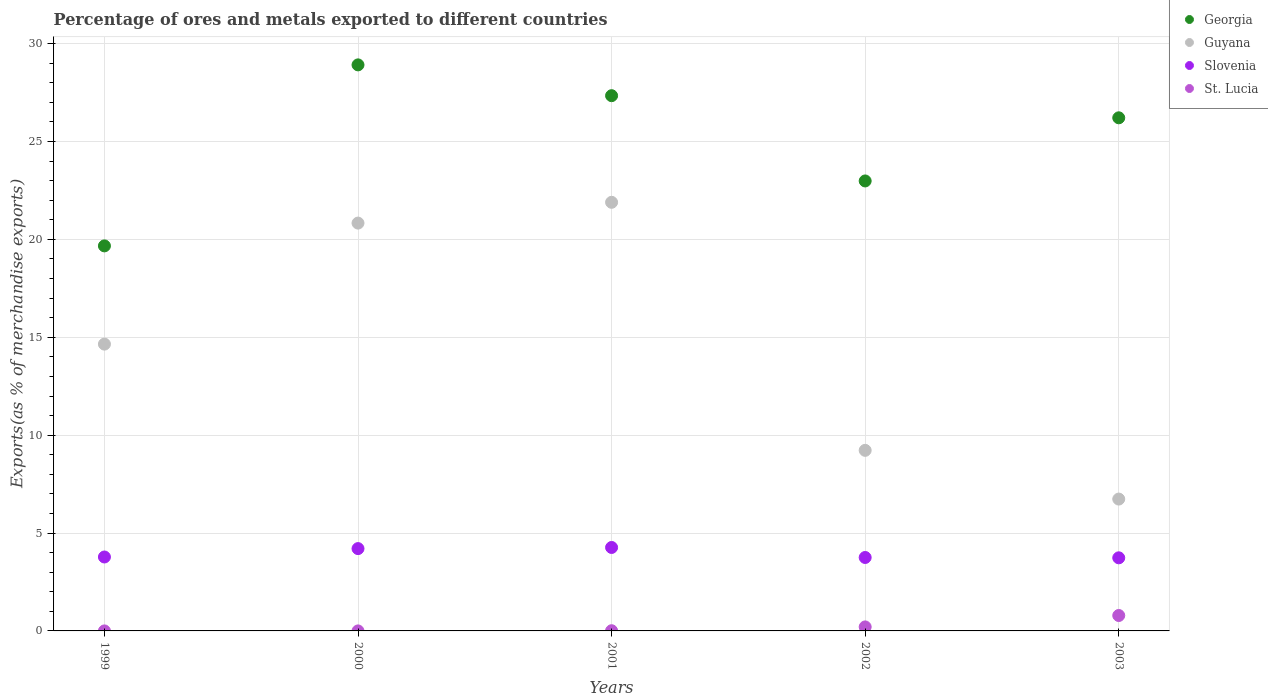How many different coloured dotlines are there?
Your answer should be compact. 4. What is the percentage of exports to different countries in Slovenia in 2000?
Your answer should be compact. 4.21. Across all years, what is the maximum percentage of exports to different countries in Guyana?
Offer a very short reply. 21.9. Across all years, what is the minimum percentage of exports to different countries in St. Lucia?
Give a very brief answer. 0. In which year was the percentage of exports to different countries in Georgia maximum?
Make the answer very short. 2000. In which year was the percentage of exports to different countries in St. Lucia minimum?
Your answer should be compact. 1999. What is the total percentage of exports to different countries in Guyana in the graph?
Your answer should be compact. 73.34. What is the difference between the percentage of exports to different countries in Slovenia in 2001 and that in 2003?
Offer a very short reply. 0.53. What is the difference between the percentage of exports to different countries in Guyana in 2003 and the percentage of exports to different countries in St. Lucia in 1999?
Your answer should be compact. 6.74. What is the average percentage of exports to different countries in Guyana per year?
Your answer should be very brief. 14.67. In the year 2002, what is the difference between the percentage of exports to different countries in Slovenia and percentage of exports to different countries in Georgia?
Provide a succinct answer. -19.24. In how many years, is the percentage of exports to different countries in Georgia greater than 20 %?
Keep it short and to the point. 4. What is the ratio of the percentage of exports to different countries in Slovenia in 2001 to that in 2003?
Your response must be concise. 1.14. Is the difference between the percentage of exports to different countries in Slovenia in 1999 and 2003 greater than the difference between the percentage of exports to different countries in Georgia in 1999 and 2003?
Offer a very short reply. Yes. What is the difference between the highest and the second highest percentage of exports to different countries in Slovenia?
Your answer should be very brief. 0.06. What is the difference between the highest and the lowest percentage of exports to different countries in Georgia?
Ensure brevity in your answer.  9.25. Is it the case that in every year, the sum of the percentage of exports to different countries in Georgia and percentage of exports to different countries in Guyana  is greater than the sum of percentage of exports to different countries in Slovenia and percentage of exports to different countries in St. Lucia?
Make the answer very short. No. Is it the case that in every year, the sum of the percentage of exports to different countries in Slovenia and percentage of exports to different countries in Georgia  is greater than the percentage of exports to different countries in St. Lucia?
Your answer should be compact. Yes. Does the percentage of exports to different countries in St. Lucia monotonically increase over the years?
Your answer should be very brief. Yes. Is the percentage of exports to different countries in Guyana strictly greater than the percentage of exports to different countries in Georgia over the years?
Ensure brevity in your answer.  No. How many years are there in the graph?
Provide a short and direct response. 5. What is the difference between two consecutive major ticks on the Y-axis?
Offer a very short reply. 5. Does the graph contain any zero values?
Provide a succinct answer. No. What is the title of the graph?
Make the answer very short. Percentage of ores and metals exported to different countries. What is the label or title of the Y-axis?
Your response must be concise. Exports(as % of merchandise exports). What is the Exports(as % of merchandise exports) of Georgia in 1999?
Offer a terse response. 19.67. What is the Exports(as % of merchandise exports) in Guyana in 1999?
Make the answer very short. 14.65. What is the Exports(as % of merchandise exports) of Slovenia in 1999?
Offer a very short reply. 3.78. What is the Exports(as % of merchandise exports) in St. Lucia in 1999?
Provide a short and direct response. 0. What is the Exports(as % of merchandise exports) in Georgia in 2000?
Your answer should be very brief. 28.92. What is the Exports(as % of merchandise exports) in Guyana in 2000?
Ensure brevity in your answer.  20.83. What is the Exports(as % of merchandise exports) of Slovenia in 2000?
Your answer should be compact. 4.21. What is the Exports(as % of merchandise exports) in St. Lucia in 2000?
Keep it short and to the point. 0. What is the Exports(as % of merchandise exports) in Georgia in 2001?
Give a very brief answer. 27.34. What is the Exports(as % of merchandise exports) of Guyana in 2001?
Offer a very short reply. 21.9. What is the Exports(as % of merchandise exports) in Slovenia in 2001?
Give a very brief answer. 4.26. What is the Exports(as % of merchandise exports) of St. Lucia in 2001?
Offer a terse response. 0.01. What is the Exports(as % of merchandise exports) in Georgia in 2002?
Provide a short and direct response. 22.99. What is the Exports(as % of merchandise exports) of Guyana in 2002?
Offer a terse response. 9.22. What is the Exports(as % of merchandise exports) of Slovenia in 2002?
Provide a short and direct response. 3.75. What is the Exports(as % of merchandise exports) of St. Lucia in 2002?
Give a very brief answer. 0.2. What is the Exports(as % of merchandise exports) of Georgia in 2003?
Your answer should be compact. 26.21. What is the Exports(as % of merchandise exports) of Guyana in 2003?
Give a very brief answer. 6.74. What is the Exports(as % of merchandise exports) of Slovenia in 2003?
Offer a terse response. 3.73. What is the Exports(as % of merchandise exports) of St. Lucia in 2003?
Your answer should be compact. 0.79. Across all years, what is the maximum Exports(as % of merchandise exports) in Georgia?
Give a very brief answer. 28.92. Across all years, what is the maximum Exports(as % of merchandise exports) of Guyana?
Offer a very short reply. 21.9. Across all years, what is the maximum Exports(as % of merchandise exports) of Slovenia?
Ensure brevity in your answer.  4.26. Across all years, what is the maximum Exports(as % of merchandise exports) of St. Lucia?
Your response must be concise. 0.79. Across all years, what is the minimum Exports(as % of merchandise exports) of Georgia?
Ensure brevity in your answer.  19.67. Across all years, what is the minimum Exports(as % of merchandise exports) in Guyana?
Your answer should be compact. 6.74. Across all years, what is the minimum Exports(as % of merchandise exports) in Slovenia?
Give a very brief answer. 3.73. Across all years, what is the minimum Exports(as % of merchandise exports) of St. Lucia?
Provide a short and direct response. 0. What is the total Exports(as % of merchandise exports) of Georgia in the graph?
Give a very brief answer. 125.13. What is the total Exports(as % of merchandise exports) in Guyana in the graph?
Your answer should be very brief. 73.34. What is the total Exports(as % of merchandise exports) of Slovenia in the graph?
Your response must be concise. 19.73. What is the difference between the Exports(as % of merchandise exports) in Georgia in 1999 and that in 2000?
Provide a short and direct response. -9.25. What is the difference between the Exports(as % of merchandise exports) of Guyana in 1999 and that in 2000?
Keep it short and to the point. -6.18. What is the difference between the Exports(as % of merchandise exports) in Slovenia in 1999 and that in 2000?
Offer a terse response. -0.43. What is the difference between the Exports(as % of merchandise exports) in St. Lucia in 1999 and that in 2000?
Keep it short and to the point. -0. What is the difference between the Exports(as % of merchandise exports) in Georgia in 1999 and that in 2001?
Your answer should be compact. -7.67. What is the difference between the Exports(as % of merchandise exports) in Guyana in 1999 and that in 2001?
Give a very brief answer. -7.25. What is the difference between the Exports(as % of merchandise exports) of Slovenia in 1999 and that in 2001?
Give a very brief answer. -0.49. What is the difference between the Exports(as % of merchandise exports) of St. Lucia in 1999 and that in 2001?
Keep it short and to the point. -0.01. What is the difference between the Exports(as % of merchandise exports) in Georgia in 1999 and that in 2002?
Your answer should be compact. -3.32. What is the difference between the Exports(as % of merchandise exports) of Guyana in 1999 and that in 2002?
Your answer should be compact. 5.43. What is the difference between the Exports(as % of merchandise exports) in Slovenia in 1999 and that in 2002?
Give a very brief answer. 0.03. What is the difference between the Exports(as % of merchandise exports) of St. Lucia in 1999 and that in 2002?
Offer a very short reply. -0.2. What is the difference between the Exports(as % of merchandise exports) of Georgia in 1999 and that in 2003?
Your answer should be very brief. -6.54. What is the difference between the Exports(as % of merchandise exports) of Guyana in 1999 and that in 2003?
Offer a very short reply. 7.92. What is the difference between the Exports(as % of merchandise exports) of Slovenia in 1999 and that in 2003?
Your answer should be very brief. 0.04. What is the difference between the Exports(as % of merchandise exports) of St. Lucia in 1999 and that in 2003?
Offer a terse response. -0.79. What is the difference between the Exports(as % of merchandise exports) in Georgia in 2000 and that in 2001?
Your answer should be compact. 1.57. What is the difference between the Exports(as % of merchandise exports) of Guyana in 2000 and that in 2001?
Provide a short and direct response. -1.06. What is the difference between the Exports(as % of merchandise exports) of Slovenia in 2000 and that in 2001?
Provide a short and direct response. -0.06. What is the difference between the Exports(as % of merchandise exports) of St. Lucia in 2000 and that in 2001?
Provide a succinct answer. -0.01. What is the difference between the Exports(as % of merchandise exports) in Georgia in 2000 and that in 2002?
Provide a short and direct response. 5.93. What is the difference between the Exports(as % of merchandise exports) in Guyana in 2000 and that in 2002?
Provide a short and direct response. 11.61. What is the difference between the Exports(as % of merchandise exports) of Slovenia in 2000 and that in 2002?
Offer a terse response. 0.45. What is the difference between the Exports(as % of merchandise exports) of St. Lucia in 2000 and that in 2002?
Offer a very short reply. -0.2. What is the difference between the Exports(as % of merchandise exports) of Georgia in 2000 and that in 2003?
Provide a short and direct response. 2.7. What is the difference between the Exports(as % of merchandise exports) in Guyana in 2000 and that in 2003?
Your answer should be compact. 14.1. What is the difference between the Exports(as % of merchandise exports) in Slovenia in 2000 and that in 2003?
Offer a terse response. 0.47. What is the difference between the Exports(as % of merchandise exports) in St. Lucia in 2000 and that in 2003?
Make the answer very short. -0.79. What is the difference between the Exports(as % of merchandise exports) of Georgia in 2001 and that in 2002?
Your answer should be compact. 4.36. What is the difference between the Exports(as % of merchandise exports) in Guyana in 2001 and that in 2002?
Provide a short and direct response. 12.67. What is the difference between the Exports(as % of merchandise exports) of Slovenia in 2001 and that in 2002?
Provide a succinct answer. 0.51. What is the difference between the Exports(as % of merchandise exports) of St. Lucia in 2001 and that in 2002?
Your answer should be compact. -0.19. What is the difference between the Exports(as % of merchandise exports) of Georgia in 2001 and that in 2003?
Offer a terse response. 1.13. What is the difference between the Exports(as % of merchandise exports) of Guyana in 2001 and that in 2003?
Ensure brevity in your answer.  15.16. What is the difference between the Exports(as % of merchandise exports) of Slovenia in 2001 and that in 2003?
Offer a terse response. 0.53. What is the difference between the Exports(as % of merchandise exports) in St. Lucia in 2001 and that in 2003?
Your response must be concise. -0.78. What is the difference between the Exports(as % of merchandise exports) of Georgia in 2002 and that in 2003?
Your response must be concise. -3.23. What is the difference between the Exports(as % of merchandise exports) in Guyana in 2002 and that in 2003?
Your response must be concise. 2.49. What is the difference between the Exports(as % of merchandise exports) in Slovenia in 2002 and that in 2003?
Offer a very short reply. 0.02. What is the difference between the Exports(as % of merchandise exports) in St. Lucia in 2002 and that in 2003?
Your response must be concise. -0.58. What is the difference between the Exports(as % of merchandise exports) of Georgia in 1999 and the Exports(as % of merchandise exports) of Guyana in 2000?
Give a very brief answer. -1.16. What is the difference between the Exports(as % of merchandise exports) of Georgia in 1999 and the Exports(as % of merchandise exports) of Slovenia in 2000?
Make the answer very short. 15.46. What is the difference between the Exports(as % of merchandise exports) of Georgia in 1999 and the Exports(as % of merchandise exports) of St. Lucia in 2000?
Your answer should be very brief. 19.67. What is the difference between the Exports(as % of merchandise exports) in Guyana in 1999 and the Exports(as % of merchandise exports) in Slovenia in 2000?
Offer a very short reply. 10.45. What is the difference between the Exports(as % of merchandise exports) of Guyana in 1999 and the Exports(as % of merchandise exports) of St. Lucia in 2000?
Give a very brief answer. 14.65. What is the difference between the Exports(as % of merchandise exports) of Slovenia in 1999 and the Exports(as % of merchandise exports) of St. Lucia in 2000?
Your response must be concise. 3.78. What is the difference between the Exports(as % of merchandise exports) in Georgia in 1999 and the Exports(as % of merchandise exports) in Guyana in 2001?
Ensure brevity in your answer.  -2.23. What is the difference between the Exports(as % of merchandise exports) in Georgia in 1999 and the Exports(as % of merchandise exports) in Slovenia in 2001?
Your answer should be compact. 15.41. What is the difference between the Exports(as % of merchandise exports) of Georgia in 1999 and the Exports(as % of merchandise exports) of St. Lucia in 2001?
Make the answer very short. 19.66. What is the difference between the Exports(as % of merchandise exports) of Guyana in 1999 and the Exports(as % of merchandise exports) of Slovenia in 2001?
Provide a short and direct response. 10.39. What is the difference between the Exports(as % of merchandise exports) in Guyana in 1999 and the Exports(as % of merchandise exports) in St. Lucia in 2001?
Make the answer very short. 14.64. What is the difference between the Exports(as % of merchandise exports) of Slovenia in 1999 and the Exports(as % of merchandise exports) of St. Lucia in 2001?
Keep it short and to the point. 3.77. What is the difference between the Exports(as % of merchandise exports) of Georgia in 1999 and the Exports(as % of merchandise exports) of Guyana in 2002?
Provide a succinct answer. 10.45. What is the difference between the Exports(as % of merchandise exports) in Georgia in 1999 and the Exports(as % of merchandise exports) in Slovenia in 2002?
Ensure brevity in your answer.  15.92. What is the difference between the Exports(as % of merchandise exports) of Georgia in 1999 and the Exports(as % of merchandise exports) of St. Lucia in 2002?
Provide a short and direct response. 19.47. What is the difference between the Exports(as % of merchandise exports) of Guyana in 1999 and the Exports(as % of merchandise exports) of Slovenia in 2002?
Provide a succinct answer. 10.9. What is the difference between the Exports(as % of merchandise exports) in Guyana in 1999 and the Exports(as % of merchandise exports) in St. Lucia in 2002?
Your answer should be compact. 14.45. What is the difference between the Exports(as % of merchandise exports) of Slovenia in 1999 and the Exports(as % of merchandise exports) of St. Lucia in 2002?
Offer a terse response. 3.57. What is the difference between the Exports(as % of merchandise exports) of Georgia in 1999 and the Exports(as % of merchandise exports) of Guyana in 2003?
Keep it short and to the point. 12.93. What is the difference between the Exports(as % of merchandise exports) of Georgia in 1999 and the Exports(as % of merchandise exports) of Slovenia in 2003?
Make the answer very short. 15.94. What is the difference between the Exports(as % of merchandise exports) of Georgia in 1999 and the Exports(as % of merchandise exports) of St. Lucia in 2003?
Provide a succinct answer. 18.88. What is the difference between the Exports(as % of merchandise exports) of Guyana in 1999 and the Exports(as % of merchandise exports) of Slovenia in 2003?
Give a very brief answer. 10.92. What is the difference between the Exports(as % of merchandise exports) of Guyana in 1999 and the Exports(as % of merchandise exports) of St. Lucia in 2003?
Offer a very short reply. 13.86. What is the difference between the Exports(as % of merchandise exports) of Slovenia in 1999 and the Exports(as % of merchandise exports) of St. Lucia in 2003?
Give a very brief answer. 2.99. What is the difference between the Exports(as % of merchandise exports) in Georgia in 2000 and the Exports(as % of merchandise exports) in Guyana in 2001?
Provide a short and direct response. 7.02. What is the difference between the Exports(as % of merchandise exports) of Georgia in 2000 and the Exports(as % of merchandise exports) of Slovenia in 2001?
Your answer should be compact. 24.65. What is the difference between the Exports(as % of merchandise exports) in Georgia in 2000 and the Exports(as % of merchandise exports) in St. Lucia in 2001?
Ensure brevity in your answer.  28.91. What is the difference between the Exports(as % of merchandise exports) of Guyana in 2000 and the Exports(as % of merchandise exports) of Slovenia in 2001?
Your answer should be compact. 16.57. What is the difference between the Exports(as % of merchandise exports) in Guyana in 2000 and the Exports(as % of merchandise exports) in St. Lucia in 2001?
Your answer should be very brief. 20.82. What is the difference between the Exports(as % of merchandise exports) in Slovenia in 2000 and the Exports(as % of merchandise exports) in St. Lucia in 2001?
Your answer should be compact. 4.2. What is the difference between the Exports(as % of merchandise exports) of Georgia in 2000 and the Exports(as % of merchandise exports) of Guyana in 2002?
Your answer should be compact. 19.69. What is the difference between the Exports(as % of merchandise exports) in Georgia in 2000 and the Exports(as % of merchandise exports) in Slovenia in 2002?
Provide a succinct answer. 25.17. What is the difference between the Exports(as % of merchandise exports) in Georgia in 2000 and the Exports(as % of merchandise exports) in St. Lucia in 2002?
Your answer should be very brief. 28.71. What is the difference between the Exports(as % of merchandise exports) of Guyana in 2000 and the Exports(as % of merchandise exports) of Slovenia in 2002?
Provide a succinct answer. 17.08. What is the difference between the Exports(as % of merchandise exports) of Guyana in 2000 and the Exports(as % of merchandise exports) of St. Lucia in 2002?
Your response must be concise. 20.63. What is the difference between the Exports(as % of merchandise exports) in Slovenia in 2000 and the Exports(as % of merchandise exports) in St. Lucia in 2002?
Keep it short and to the point. 4. What is the difference between the Exports(as % of merchandise exports) in Georgia in 2000 and the Exports(as % of merchandise exports) in Guyana in 2003?
Give a very brief answer. 22.18. What is the difference between the Exports(as % of merchandise exports) of Georgia in 2000 and the Exports(as % of merchandise exports) of Slovenia in 2003?
Provide a succinct answer. 25.18. What is the difference between the Exports(as % of merchandise exports) in Georgia in 2000 and the Exports(as % of merchandise exports) in St. Lucia in 2003?
Keep it short and to the point. 28.13. What is the difference between the Exports(as % of merchandise exports) of Guyana in 2000 and the Exports(as % of merchandise exports) of Slovenia in 2003?
Provide a short and direct response. 17.1. What is the difference between the Exports(as % of merchandise exports) of Guyana in 2000 and the Exports(as % of merchandise exports) of St. Lucia in 2003?
Provide a short and direct response. 20.05. What is the difference between the Exports(as % of merchandise exports) in Slovenia in 2000 and the Exports(as % of merchandise exports) in St. Lucia in 2003?
Keep it short and to the point. 3.42. What is the difference between the Exports(as % of merchandise exports) of Georgia in 2001 and the Exports(as % of merchandise exports) of Guyana in 2002?
Give a very brief answer. 18.12. What is the difference between the Exports(as % of merchandise exports) in Georgia in 2001 and the Exports(as % of merchandise exports) in Slovenia in 2002?
Give a very brief answer. 23.59. What is the difference between the Exports(as % of merchandise exports) of Georgia in 2001 and the Exports(as % of merchandise exports) of St. Lucia in 2002?
Keep it short and to the point. 27.14. What is the difference between the Exports(as % of merchandise exports) of Guyana in 2001 and the Exports(as % of merchandise exports) of Slovenia in 2002?
Make the answer very short. 18.14. What is the difference between the Exports(as % of merchandise exports) in Guyana in 2001 and the Exports(as % of merchandise exports) in St. Lucia in 2002?
Give a very brief answer. 21.69. What is the difference between the Exports(as % of merchandise exports) of Slovenia in 2001 and the Exports(as % of merchandise exports) of St. Lucia in 2002?
Give a very brief answer. 4.06. What is the difference between the Exports(as % of merchandise exports) of Georgia in 2001 and the Exports(as % of merchandise exports) of Guyana in 2003?
Ensure brevity in your answer.  20.61. What is the difference between the Exports(as % of merchandise exports) of Georgia in 2001 and the Exports(as % of merchandise exports) of Slovenia in 2003?
Your answer should be very brief. 23.61. What is the difference between the Exports(as % of merchandise exports) in Georgia in 2001 and the Exports(as % of merchandise exports) in St. Lucia in 2003?
Provide a succinct answer. 26.56. What is the difference between the Exports(as % of merchandise exports) in Guyana in 2001 and the Exports(as % of merchandise exports) in Slovenia in 2003?
Offer a terse response. 18.16. What is the difference between the Exports(as % of merchandise exports) of Guyana in 2001 and the Exports(as % of merchandise exports) of St. Lucia in 2003?
Give a very brief answer. 21.11. What is the difference between the Exports(as % of merchandise exports) in Slovenia in 2001 and the Exports(as % of merchandise exports) in St. Lucia in 2003?
Ensure brevity in your answer.  3.48. What is the difference between the Exports(as % of merchandise exports) of Georgia in 2002 and the Exports(as % of merchandise exports) of Guyana in 2003?
Provide a short and direct response. 16.25. What is the difference between the Exports(as % of merchandise exports) of Georgia in 2002 and the Exports(as % of merchandise exports) of Slovenia in 2003?
Keep it short and to the point. 19.25. What is the difference between the Exports(as % of merchandise exports) in Georgia in 2002 and the Exports(as % of merchandise exports) in St. Lucia in 2003?
Your answer should be compact. 22.2. What is the difference between the Exports(as % of merchandise exports) in Guyana in 2002 and the Exports(as % of merchandise exports) in Slovenia in 2003?
Provide a succinct answer. 5.49. What is the difference between the Exports(as % of merchandise exports) in Guyana in 2002 and the Exports(as % of merchandise exports) in St. Lucia in 2003?
Make the answer very short. 8.44. What is the difference between the Exports(as % of merchandise exports) in Slovenia in 2002 and the Exports(as % of merchandise exports) in St. Lucia in 2003?
Give a very brief answer. 2.96. What is the average Exports(as % of merchandise exports) of Georgia per year?
Provide a short and direct response. 25.03. What is the average Exports(as % of merchandise exports) in Guyana per year?
Your answer should be compact. 14.67. What is the average Exports(as % of merchandise exports) of Slovenia per year?
Provide a short and direct response. 3.95. What is the average Exports(as % of merchandise exports) in St. Lucia per year?
Offer a very short reply. 0.2. In the year 1999, what is the difference between the Exports(as % of merchandise exports) in Georgia and Exports(as % of merchandise exports) in Guyana?
Provide a short and direct response. 5.02. In the year 1999, what is the difference between the Exports(as % of merchandise exports) of Georgia and Exports(as % of merchandise exports) of Slovenia?
Offer a very short reply. 15.89. In the year 1999, what is the difference between the Exports(as % of merchandise exports) in Georgia and Exports(as % of merchandise exports) in St. Lucia?
Offer a terse response. 19.67. In the year 1999, what is the difference between the Exports(as % of merchandise exports) of Guyana and Exports(as % of merchandise exports) of Slovenia?
Offer a terse response. 10.87. In the year 1999, what is the difference between the Exports(as % of merchandise exports) in Guyana and Exports(as % of merchandise exports) in St. Lucia?
Keep it short and to the point. 14.65. In the year 1999, what is the difference between the Exports(as % of merchandise exports) in Slovenia and Exports(as % of merchandise exports) in St. Lucia?
Ensure brevity in your answer.  3.78. In the year 2000, what is the difference between the Exports(as % of merchandise exports) in Georgia and Exports(as % of merchandise exports) in Guyana?
Keep it short and to the point. 8.08. In the year 2000, what is the difference between the Exports(as % of merchandise exports) in Georgia and Exports(as % of merchandise exports) in Slovenia?
Make the answer very short. 24.71. In the year 2000, what is the difference between the Exports(as % of merchandise exports) in Georgia and Exports(as % of merchandise exports) in St. Lucia?
Ensure brevity in your answer.  28.92. In the year 2000, what is the difference between the Exports(as % of merchandise exports) in Guyana and Exports(as % of merchandise exports) in Slovenia?
Offer a terse response. 16.63. In the year 2000, what is the difference between the Exports(as % of merchandise exports) in Guyana and Exports(as % of merchandise exports) in St. Lucia?
Your response must be concise. 20.83. In the year 2000, what is the difference between the Exports(as % of merchandise exports) in Slovenia and Exports(as % of merchandise exports) in St. Lucia?
Make the answer very short. 4.21. In the year 2001, what is the difference between the Exports(as % of merchandise exports) in Georgia and Exports(as % of merchandise exports) in Guyana?
Provide a succinct answer. 5.45. In the year 2001, what is the difference between the Exports(as % of merchandise exports) of Georgia and Exports(as % of merchandise exports) of Slovenia?
Offer a very short reply. 23.08. In the year 2001, what is the difference between the Exports(as % of merchandise exports) in Georgia and Exports(as % of merchandise exports) in St. Lucia?
Your answer should be compact. 27.33. In the year 2001, what is the difference between the Exports(as % of merchandise exports) of Guyana and Exports(as % of merchandise exports) of Slovenia?
Give a very brief answer. 17.63. In the year 2001, what is the difference between the Exports(as % of merchandise exports) of Guyana and Exports(as % of merchandise exports) of St. Lucia?
Offer a terse response. 21.89. In the year 2001, what is the difference between the Exports(as % of merchandise exports) of Slovenia and Exports(as % of merchandise exports) of St. Lucia?
Offer a very short reply. 4.25. In the year 2002, what is the difference between the Exports(as % of merchandise exports) of Georgia and Exports(as % of merchandise exports) of Guyana?
Your answer should be very brief. 13.76. In the year 2002, what is the difference between the Exports(as % of merchandise exports) in Georgia and Exports(as % of merchandise exports) in Slovenia?
Your answer should be very brief. 19.24. In the year 2002, what is the difference between the Exports(as % of merchandise exports) of Georgia and Exports(as % of merchandise exports) of St. Lucia?
Provide a short and direct response. 22.78. In the year 2002, what is the difference between the Exports(as % of merchandise exports) of Guyana and Exports(as % of merchandise exports) of Slovenia?
Provide a succinct answer. 5.47. In the year 2002, what is the difference between the Exports(as % of merchandise exports) in Guyana and Exports(as % of merchandise exports) in St. Lucia?
Offer a terse response. 9.02. In the year 2002, what is the difference between the Exports(as % of merchandise exports) in Slovenia and Exports(as % of merchandise exports) in St. Lucia?
Offer a terse response. 3.55. In the year 2003, what is the difference between the Exports(as % of merchandise exports) of Georgia and Exports(as % of merchandise exports) of Guyana?
Ensure brevity in your answer.  19.48. In the year 2003, what is the difference between the Exports(as % of merchandise exports) of Georgia and Exports(as % of merchandise exports) of Slovenia?
Ensure brevity in your answer.  22.48. In the year 2003, what is the difference between the Exports(as % of merchandise exports) in Georgia and Exports(as % of merchandise exports) in St. Lucia?
Provide a short and direct response. 25.43. In the year 2003, what is the difference between the Exports(as % of merchandise exports) in Guyana and Exports(as % of merchandise exports) in Slovenia?
Your answer should be very brief. 3. In the year 2003, what is the difference between the Exports(as % of merchandise exports) in Guyana and Exports(as % of merchandise exports) in St. Lucia?
Ensure brevity in your answer.  5.95. In the year 2003, what is the difference between the Exports(as % of merchandise exports) in Slovenia and Exports(as % of merchandise exports) in St. Lucia?
Make the answer very short. 2.95. What is the ratio of the Exports(as % of merchandise exports) in Georgia in 1999 to that in 2000?
Give a very brief answer. 0.68. What is the ratio of the Exports(as % of merchandise exports) of Guyana in 1999 to that in 2000?
Provide a short and direct response. 0.7. What is the ratio of the Exports(as % of merchandise exports) in Slovenia in 1999 to that in 2000?
Offer a terse response. 0.9. What is the ratio of the Exports(as % of merchandise exports) of St. Lucia in 1999 to that in 2000?
Provide a succinct answer. 0.72. What is the ratio of the Exports(as % of merchandise exports) in Georgia in 1999 to that in 2001?
Give a very brief answer. 0.72. What is the ratio of the Exports(as % of merchandise exports) in Guyana in 1999 to that in 2001?
Provide a short and direct response. 0.67. What is the ratio of the Exports(as % of merchandise exports) of Slovenia in 1999 to that in 2001?
Your response must be concise. 0.89. What is the ratio of the Exports(as % of merchandise exports) of St. Lucia in 1999 to that in 2001?
Give a very brief answer. 0.01. What is the ratio of the Exports(as % of merchandise exports) of Georgia in 1999 to that in 2002?
Provide a short and direct response. 0.86. What is the ratio of the Exports(as % of merchandise exports) of Guyana in 1999 to that in 2002?
Keep it short and to the point. 1.59. What is the ratio of the Exports(as % of merchandise exports) of Georgia in 1999 to that in 2003?
Offer a terse response. 0.75. What is the ratio of the Exports(as % of merchandise exports) in Guyana in 1999 to that in 2003?
Offer a very short reply. 2.18. What is the ratio of the Exports(as % of merchandise exports) of Slovenia in 1999 to that in 2003?
Ensure brevity in your answer.  1.01. What is the ratio of the Exports(as % of merchandise exports) of Georgia in 2000 to that in 2001?
Your response must be concise. 1.06. What is the ratio of the Exports(as % of merchandise exports) in Guyana in 2000 to that in 2001?
Ensure brevity in your answer.  0.95. What is the ratio of the Exports(as % of merchandise exports) of Slovenia in 2000 to that in 2001?
Provide a succinct answer. 0.99. What is the ratio of the Exports(as % of merchandise exports) of St. Lucia in 2000 to that in 2001?
Provide a succinct answer. 0.02. What is the ratio of the Exports(as % of merchandise exports) in Georgia in 2000 to that in 2002?
Give a very brief answer. 1.26. What is the ratio of the Exports(as % of merchandise exports) in Guyana in 2000 to that in 2002?
Your answer should be very brief. 2.26. What is the ratio of the Exports(as % of merchandise exports) of Slovenia in 2000 to that in 2002?
Give a very brief answer. 1.12. What is the ratio of the Exports(as % of merchandise exports) of St. Lucia in 2000 to that in 2002?
Keep it short and to the point. 0. What is the ratio of the Exports(as % of merchandise exports) of Georgia in 2000 to that in 2003?
Your response must be concise. 1.1. What is the ratio of the Exports(as % of merchandise exports) of Guyana in 2000 to that in 2003?
Your answer should be compact. 3.09. What is the ratio of the Exports(as % of merchandise exports) of Slovenia in 2000 to that in 2003?
Your answer should be very brief. 1.13. What is the ratio of the Exports(as % of merchandise exports) in Georgia in 2001 to that in 2002?
Your answer should be compact. 1.19. What is the ratio of the Exports(as % of merchandise exports) of Guyana in 2001 to that in 2002?
Make the answer very short. 2.37. What is the ratio of the Exports(as % of merchandise exports) of Slovenia in 2001 to that in 2002?
Offer a terse response. 1.14. What is the ratio of the Exports(as % of merchandise exports) of St. Lucia in 2001 to that in 2002?
Provide a short and direct response. 0.05. What is the ratio of the Exports(as % of merchandise exports) of Georgia in 2001 to that in 2003?
Offer a terse response. 1.04. What is the ratio of the Exports(as % of merchandise exports) in Guyana in 2001 to that in 2003?
Provide a succinct answer. 3.25. What is the ratio of the Exports(as % of merchandise exports) in Slovenia in 2001 to that in 2003?
Give a very brief answer. 1.14. What is the ratio of the Exports(as % of merchandise exports) of St. Lucia in 2001 to that in 2003?
Ensure brevity in your answer.  0.01. What is the ratio of the Exports(as % of merchandise exports) in Georgia in 2002 to that in 2003?
Provide a short and direct response. 0.88. What is the ratio of the Exports(as % of merchandise exports) of Guyana in 2002 to that in 2003?
Provide a short and direct response. 1.37. What is the ratio of the Exports(as % of merchandise exports) in Slovenia in 2002 to that in 2003?
Keep it short and to the point. 1. What is the ratio of the Exports(as % of merchandise exports) of St. Lucia in 2002 to that in 2003?
Offer a very short reply. 0.26. What is the difference between the highest and the second highest Exports(as % of merchandise exports) in Georgia?
Make the answer very short. 1.57. What is the difference between the highest and the second highest Exports(as % of merchandise exports) in Guyana?
Provide a short and direct response. 1.06. What is the difference between the highest and the second highest Exports(as % of merchandise exports) of Slovenia?
Keep it short and to the point. 0.06. What is the difference between the highest and the second highest Exports(as % of merchandise exports) in St. Lucia?
Keep it short and to the point. 0.58. What is the difference between the highest and the lowest Exports(as % of merchandise exports) in Georgia?
Offer a terse response. 9.25. What is the difference between the highest and the lowest Exports(as % of merchandise exports) of Guyana?
Ensure brevity in your answer.  15.16. What is the difference between the highest and the lowest Exports(as % of merchandise exports) in Slovenia?
Make the answer very short. 0.53. What is the difference between the highest and the lowest Exports(as % of merchandise exports) of St. Lucia?
Provide a succinct answer. 0.79. 